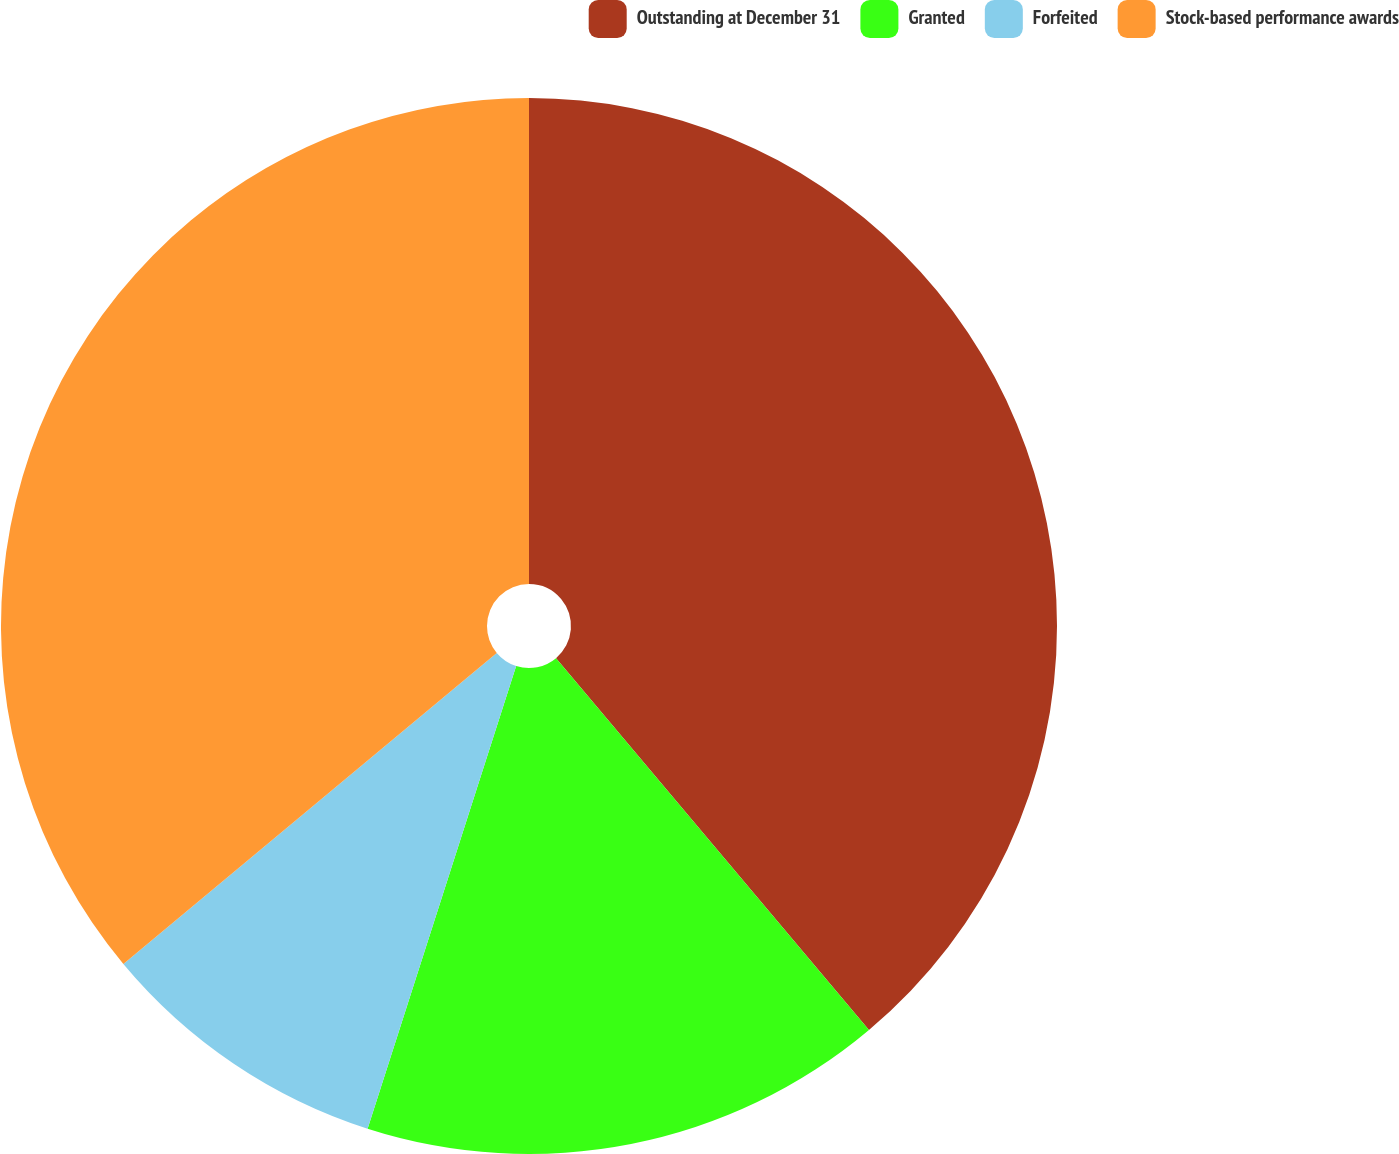<chart> <loc_0><loc_0><loc_500><loc_500><pie_chart><fcel>Outstanding at December 31<fcel>Granted<fcel>Forfeited<fcel>Stock-based performance awards<nl><fcel>38.87%<fcel>16.08%<fcel>9.0%<fcel>36.06%<nl></chart> 